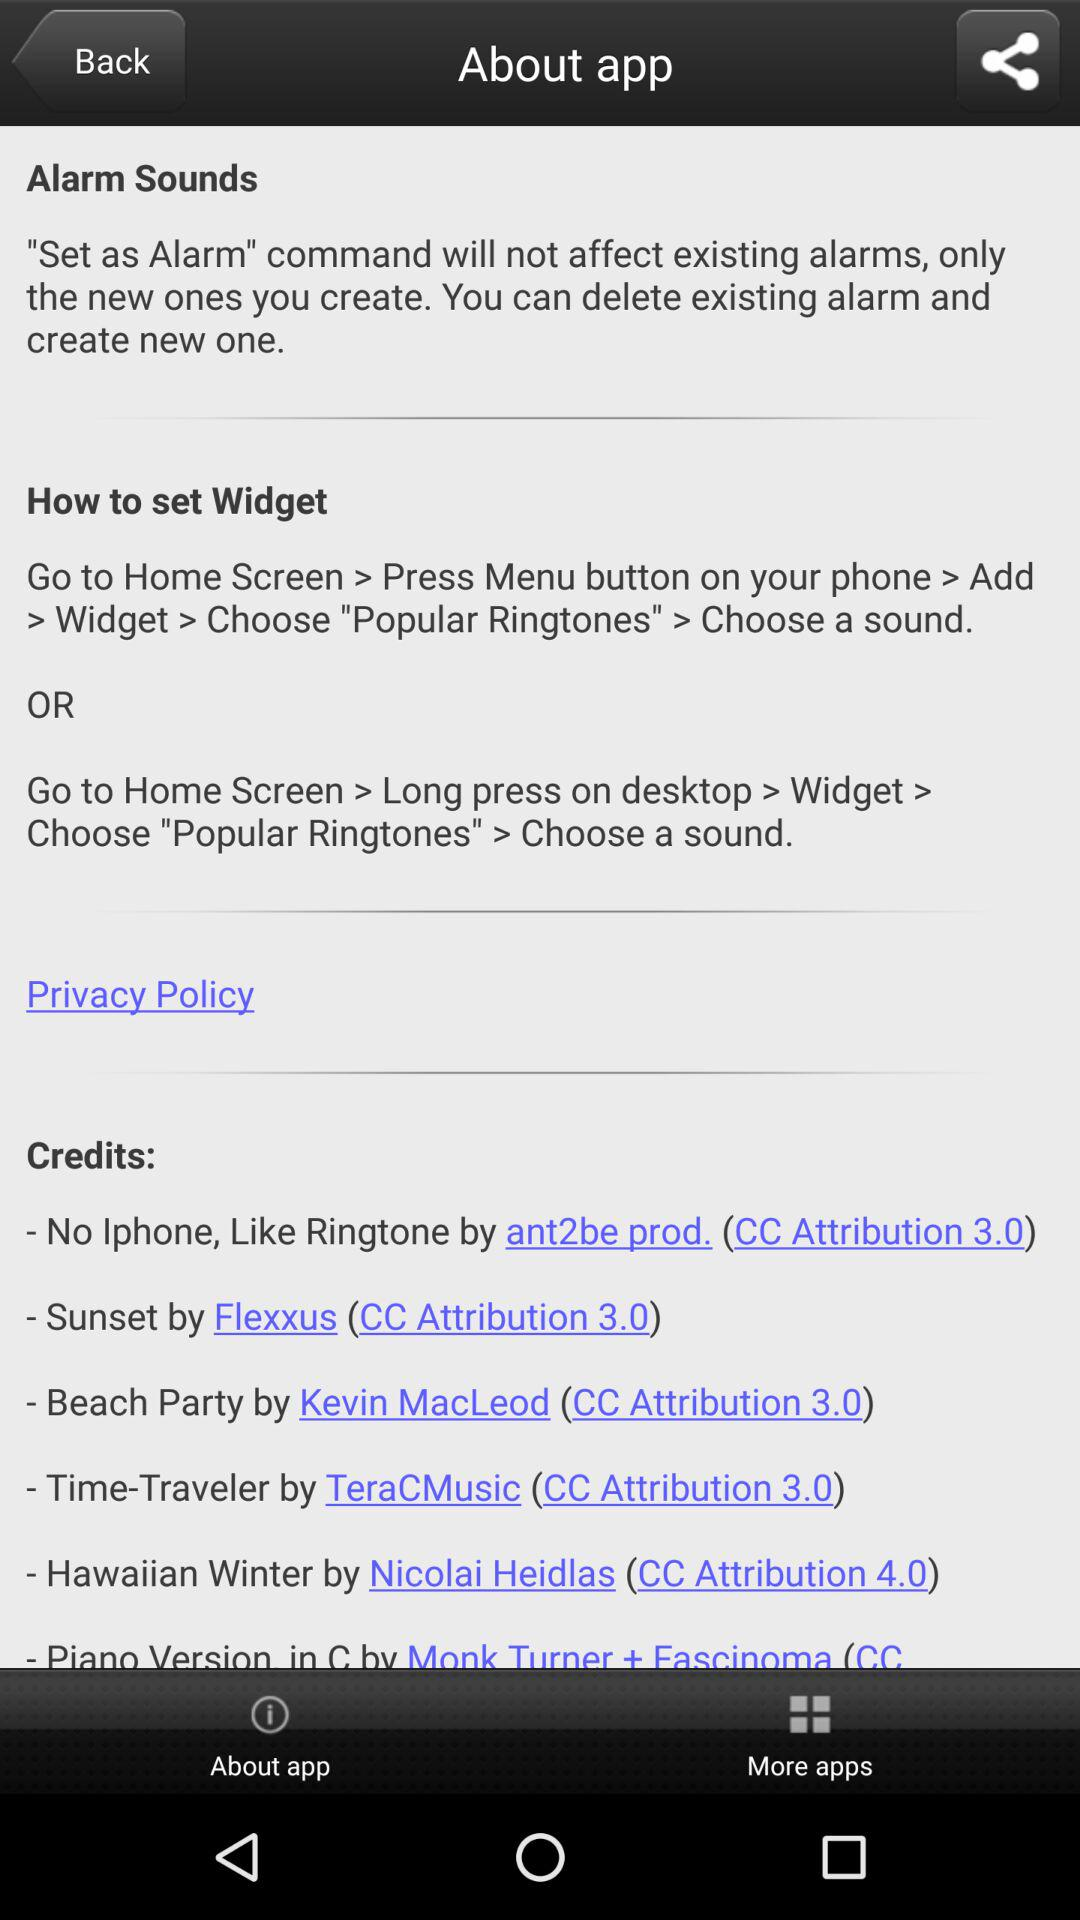How many of the credits are attributed to a creative commons license?
Answer the question using a single word or phrase. 6 